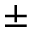Convert formula to latex. <formula><loc_0><loc_0><loc_500><loc_500>\pm</formula> 